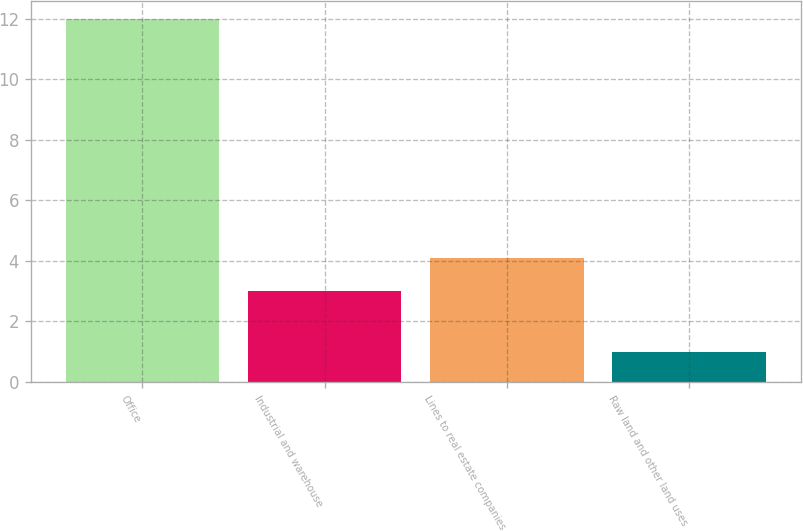<chart> <loc_0><loc_0><loc_500><loc_500><bar_chart><fcel>Office<fcel>Industrial and warehouse<fcel>Lines to real estate companies<fcel>Raw land and other land uses<nl><fcel>12<fcel>3<fcel>4.1<fcel>1<nl></chart> 